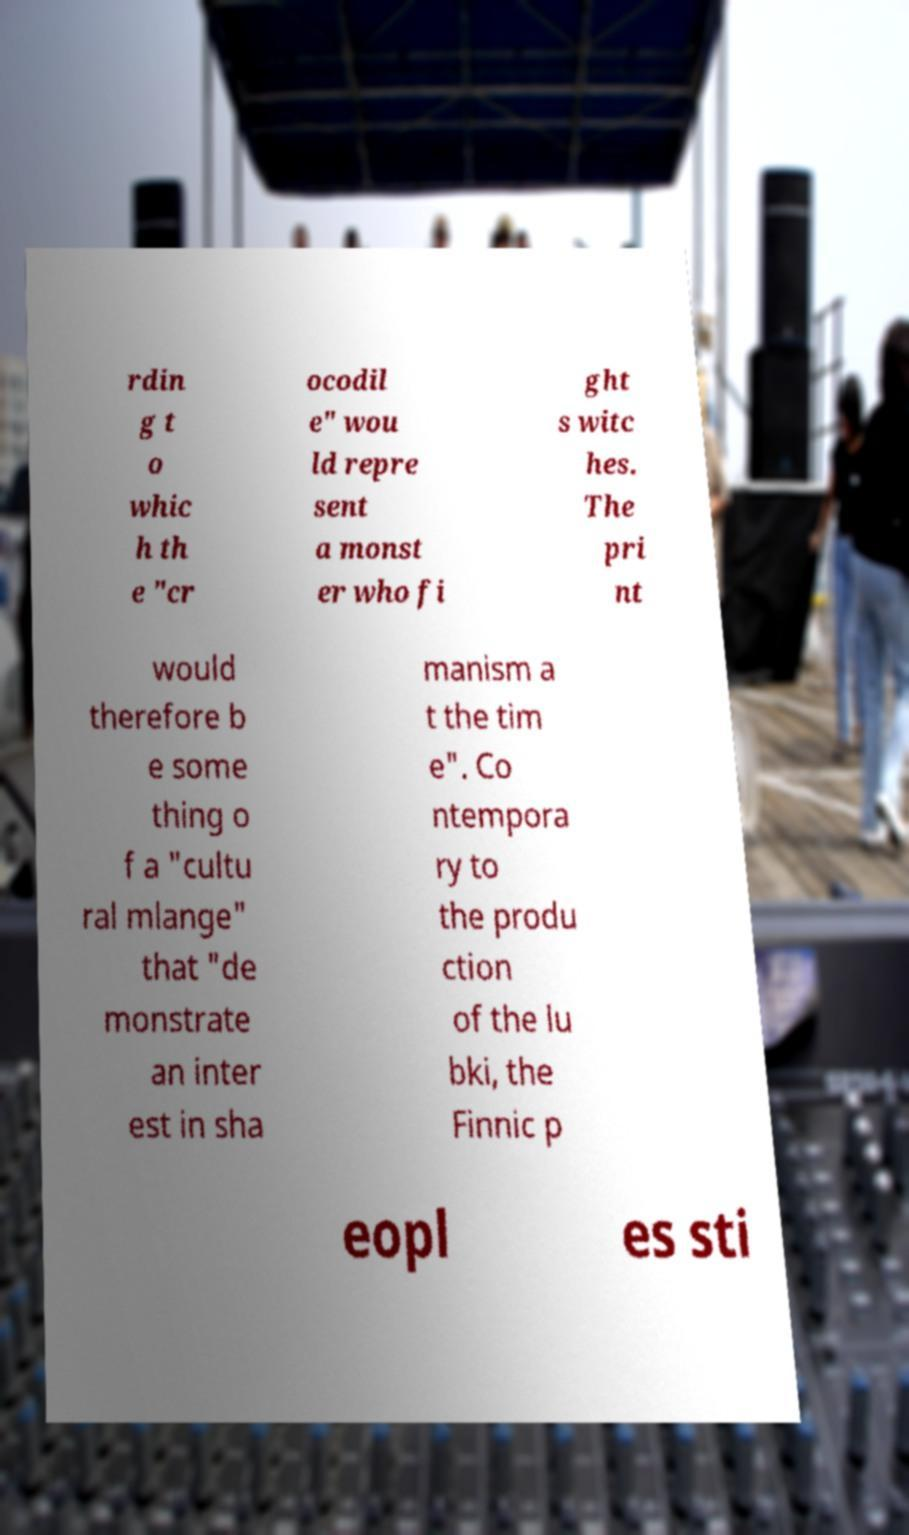Please identify and transcribe the text found in this image. rdin g t o whic h th e "cr ocodil e" wou ld repre sent a monst er who fi ght s witc hes. The pri nt would therefore b e some thing o f a "cultu ral mlange" that "de monstrate an inter est in sha manism a t the tim e". Co ntempora ry to the produ ction of the lu bki, the Finnic p eopl es sti 